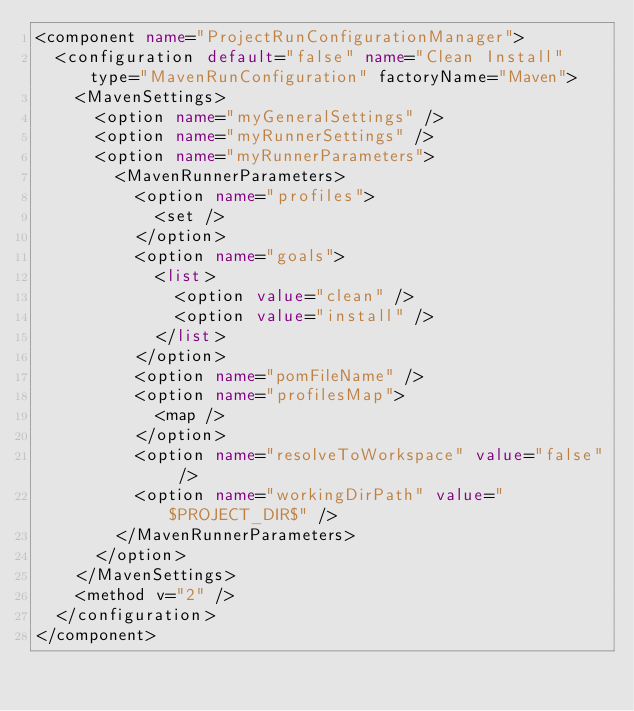<code> <loc_0><loc_0><loc_500><loc_500><_XML_><component name="ProjectRunConfigurationManager">
  <configuration default="false" name="Clean Install" type="MavenRunConfiguration" factoryName="Maven">
    <MavenSettings>
      <option name="myGeneralSettings" />
      <option name="myRunnerSettings" />
      <option name="myRunnerParameters">
        <MavenRunnerParameters>
          <option name="profiles">
            <set />
          </option>
          <option name="goals">
            <list>
              <option value="clean" />
              <option value="install" />
            </list>
          </option>
          <option name="pomFileName" />
          <option name="profilesMap">
            <map />
          </option>
          <option name="resolveToWorkspace" value="false" />
          <option name="workingDirPath" value="$PROJECT_DIR$" />
        </MavenRunnerParameters>
      </option>
    </MavenSettings>
    <method v="2" />
  </configuration>
</component></code> 